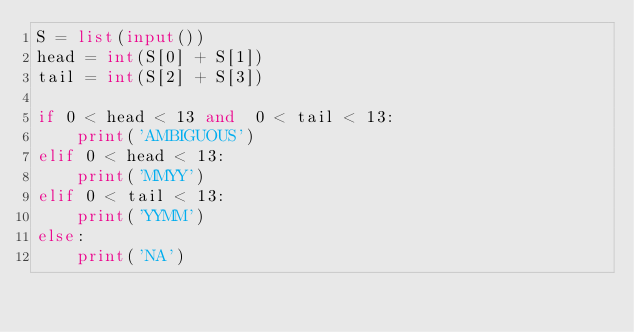Convert code to text. <code><loc_0><loc_0><loc_500><loc_500><_Python_>S = list(input())
head = int(S[0] + S[1])
tail = int(S[2] + S[3])

if 0 < head < 13 and  0 < tail < 13:
    print('AMBIGUOUS')
elif 0 < head < 13:
    print('MMYY')
elif 0 < tail < 13:
    print('YYMM')
else:
    print('NA')
</code> 